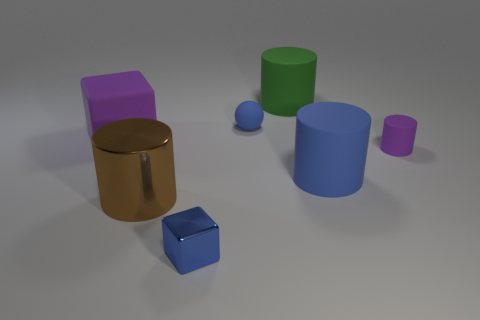Subtract all blue cylinders. Subtract all brown spheres. How many cylinders are left? 3 Add 1 small metal spheres. How many objects exist? 8 Subtract all balls. How many objects are left? 6 Subtract all small matte cylinders. Subtract all tiny blue metal blocks. How many objects are left? 5 Add 4 blue cylinders. How many blue cylinders are left? 5 Add 7 brown objects. How many brown objects exist? 8 Subtract 1 purple cylinders. How many objects are left? 6 